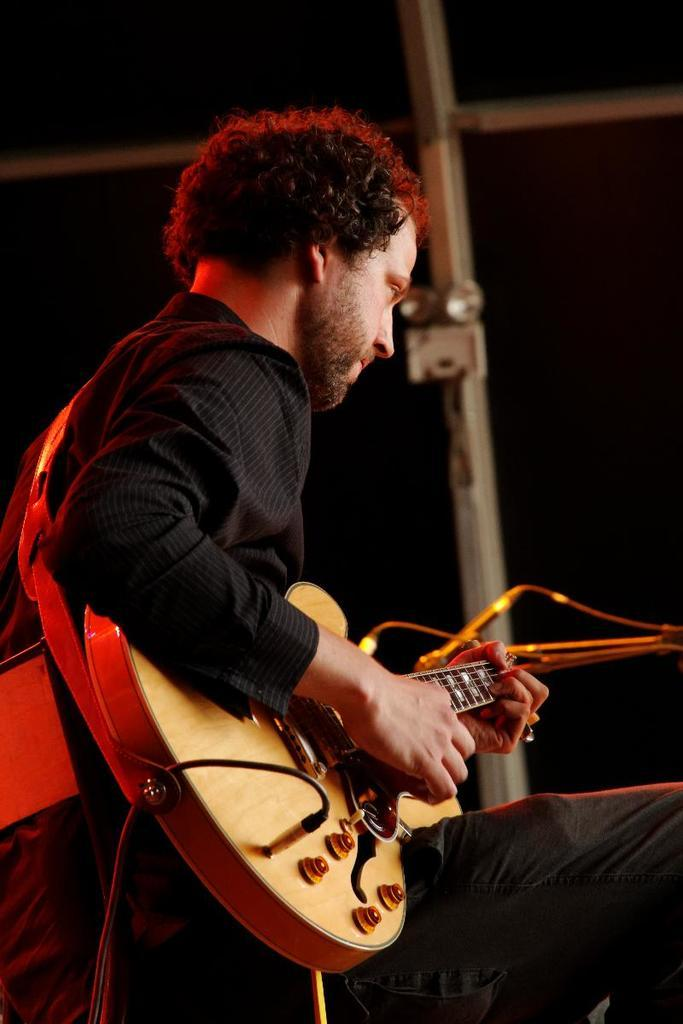What is the man in the image doing? A: The man is playing a guitar. What is the man wearing in the image? The man is wearing a black dress. Can you describe the man's appearance in the image? The man has long hair. What is connected to the guitar in the image? Cables are attached to the guitar. What can be seen in the background of the image? There is a wall and lights in the background of the image. How much profit did the goat make from selling the guitar in the image? There is no goat present in the image, and the man is playing the guitar, not selling it. 